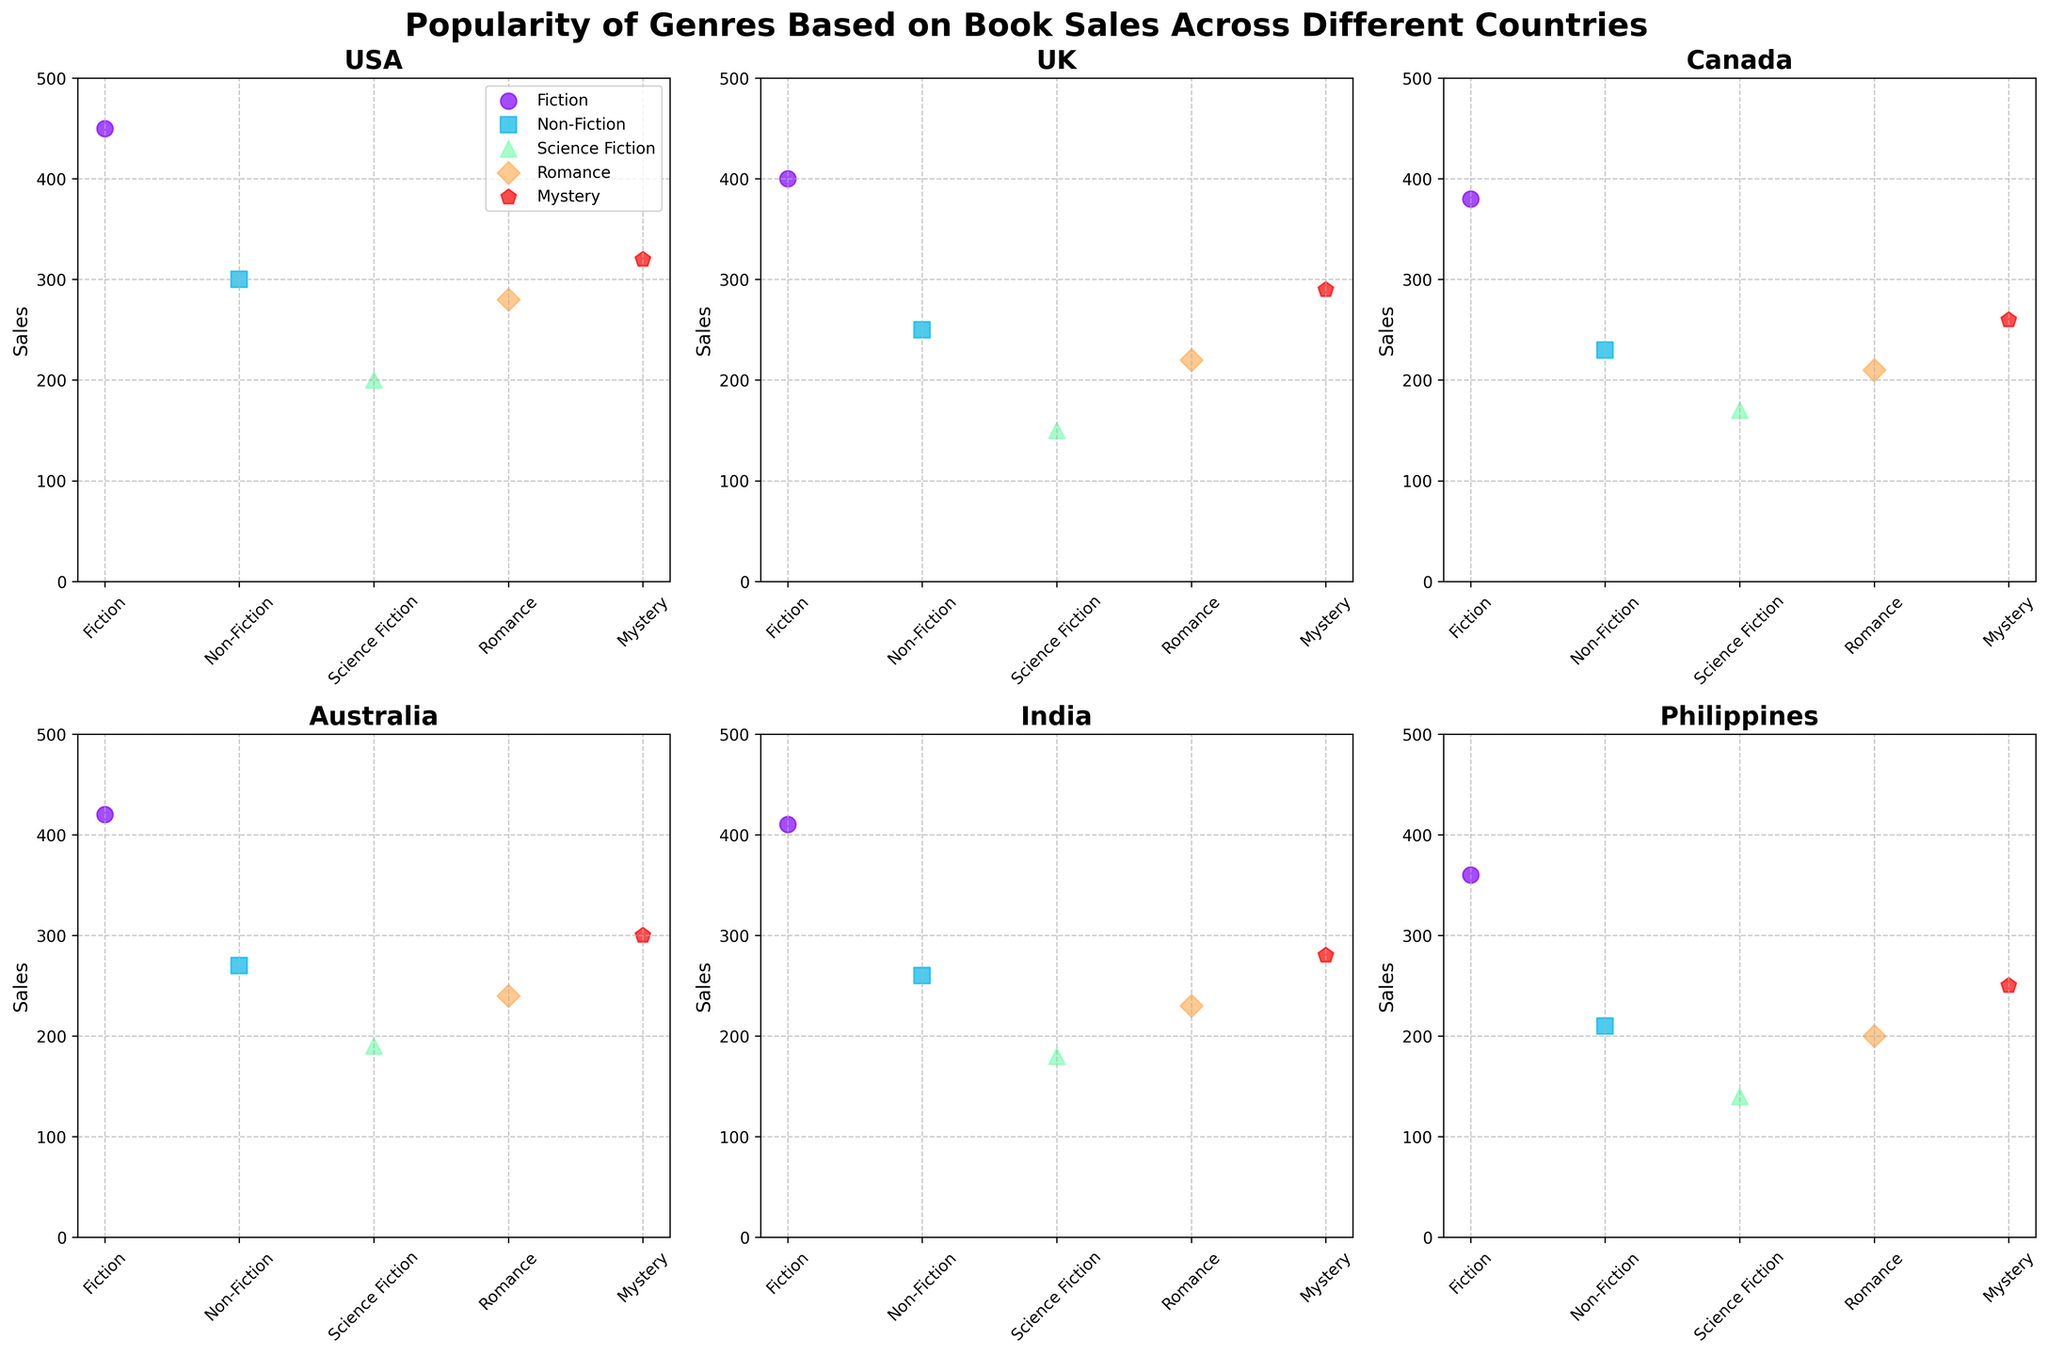What is the title of the figure? The title is displayed at the top of the figure, summarizing the content that will be shown in the subplots.
Answer: Popularity of Genres Based on Book Sales Across Different Countries How many countries are represented in the subplots? Look at the subplot titles which represent different countries. Count the number of subplots to determine how many countries are included.
Answer: 6 Which genres are represented by data points in each subplot? Each subplot contains data points that represent different genres. The genres can be identified by the legend in the first subplot and by looking at the scatter points' markers and colors across all subplots.
Answer: Fiction, Non-Fiction, Science Fiction, Romance, Mystery For which country is Fiction the most popular genre based on book sales? Examine each subplot and identify the highest sales point for the Fiction genre. Fiction sales are the highest in the subplot where the Fiction data point reaches the highest value.
Answer: USA In which country does Romance have the lowest sales? Review the sales value for Romance in each subplot and look for the smallest scatter point in the Romance genre.
Answer: Philippines What is the total sales for Science Fiction across all countries? Identify the sales for Science Fiction from each subplot, then sum them up. Sales values are 200 (USA), 150 (UK), 170 (Canada), 190 (Australia), 180 (India), and 140 (Philippines).
Answer: 1030 Which genre has the most consistent sales across all countries? Look at the scatter points for each genre across all subplots and identify the genre which has the least variability in its sales values.
Answer: Fiction Compare the sales of Non-Fiction between USA and India. Which country has higher sales? Identify the sales values for Non-Fiction in the USA and India's subplots and compare them directly. USA has 300 and India has 260.
Answer: USA Which country has the highest sales for Mystery genre? Find the subplot with the highest value for the Mystery genre. The sales for Mystery are highest where the Mystery scatter point reaches the highest position.
Answer: USA What is the average sales of Romance genre across all countries? Calculate the average by summing the sales for Romance in each country (280 + 220 + 210 + 240 + 230 + 200) and then divide by the number of countries (6).
Answer: 230 